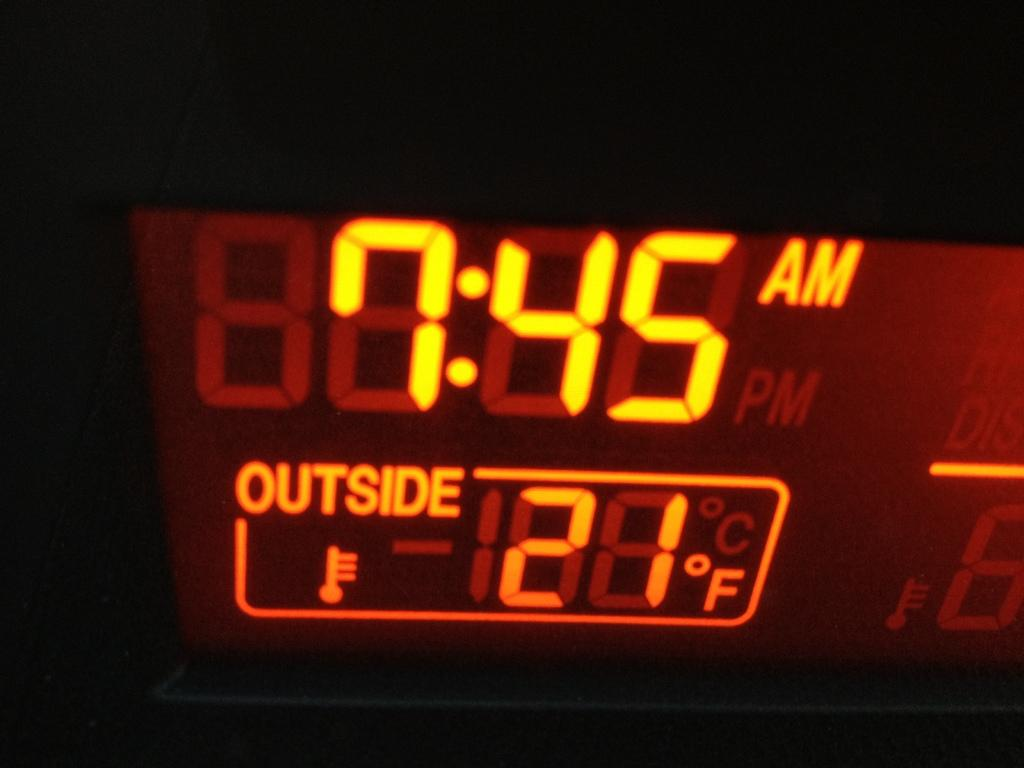Provide a one-sentence caption for the provided image. A close up of a device telling the time and the outside temperature. 